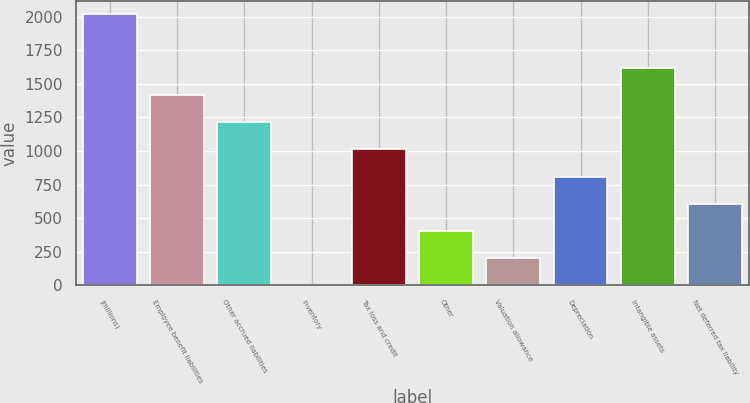<chart> <loc_0><loc_0><loc_500><loc_500><bar_chart><fcel>(millions)<fcel>Employee benefit liabilities<fcel>Other accrued liabilities<fcel>Inventory<fcel>Tax loss and credit<fcel>Other<fcel>Valuation allowance<fcel>Depreciation<fcel>Intangible assets<fcel>Net deferred tax liability<nl><fcel>2016<fcel>1412.85<fcel>1211.8<fcel>5.5<fcel>1010.75<fcel>407.6<fcel>206.55<fcel>809.7<fcel>1613.9<fcel>608.65<nl></chart> 